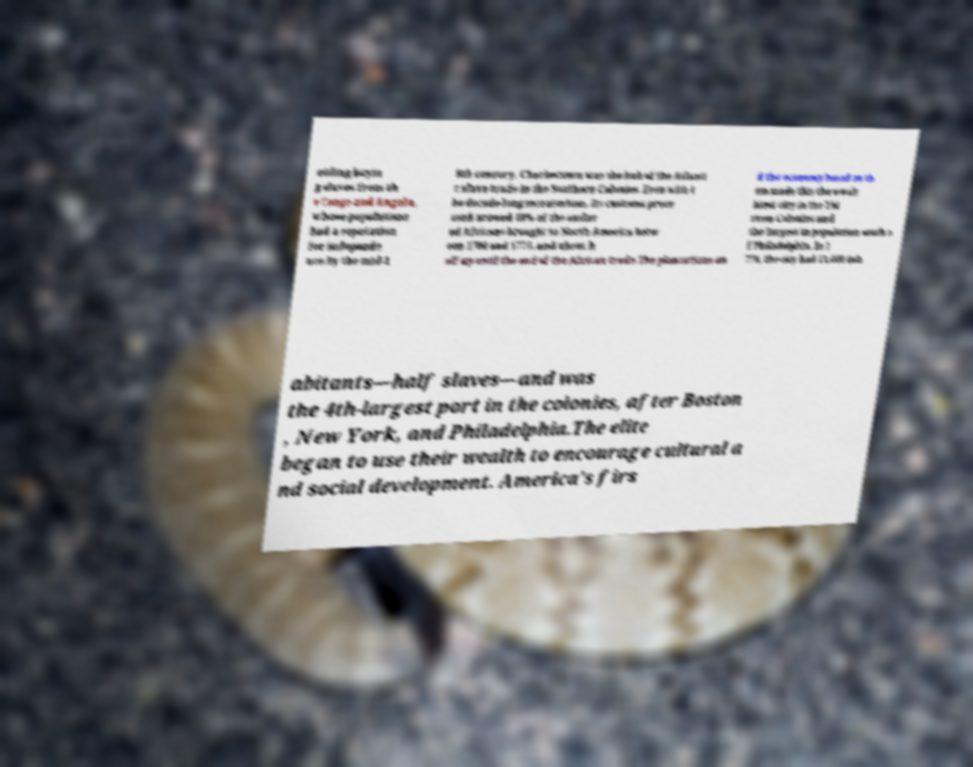Please identify and transcribe the text found in this image. oiding buyin g slaves from th e Congo and Angola, whose populations had a reputation for independe nce.By the mid-1 8th century, Charlestown was the hub of the Atlanti c slave trade in the Southern Colonies. Even with t he decade-long moratorium, its customs proce ssed around 40% of the enslav ed Africans brought to North America betw een 1700 and 1775, and about h alf up until the end of the African trade.The plantations an d the economy based on th em made this the wealt hiest city in the Thi rteen Colonies and the largest in population south o f Philadelphia. In 1 770, the city had 11,000 inh abitants—half slaves—and was the 4th-largest port in the colonies, after Boston , New York, and Philadelphia.The elite began to use their wealth to encourage cultural a nd social development. America's firs 